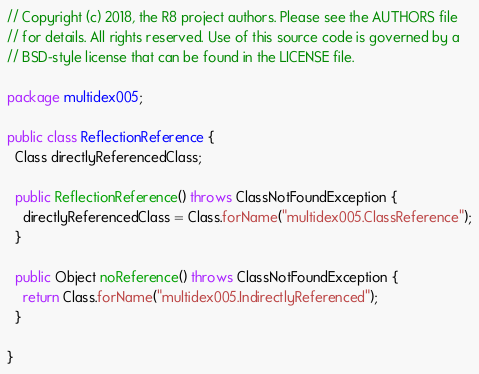Convert code to text. <code><loc_0><loc_0><loc_500><loc_500><_Java_>// Copyright (c) 2018, the R8 project authors. Please see the AUTHORS file
// for details. All rights reserved. Use of this source code is governed by a
// BSD-style license that can be found in the LICENSE file.

package multidex005;

public class ReflectionReference {
  Class directlyReferencedClass;

  public ReflectionReference() throws ClassNotFoundException {
    directlyReferencedClass = Class.forName("multidex005.ClassReference");
  }

  public Object noReference() throws ClassNotFoundException {
    return Class.forName("multidex005.IndirectlyReferenced");
  }

}
</code> 